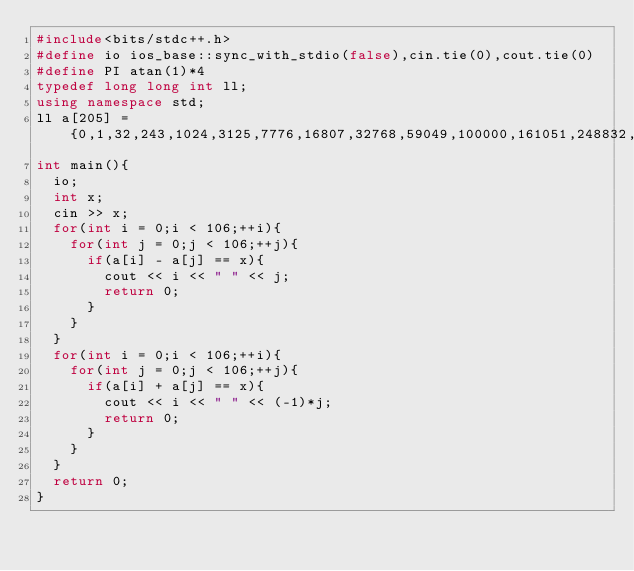<code> <loc_0><loc_0><loc_500><loc_500><_C++_>#include<bits/stdc++.h>
#define io ios_base::sync_with_stdio(false),cin.tie(0),cout.tie(0)
#define PI atan(1)*4
typedef long long int ll;
using namespace std;
ll a[205] = {0,1,32,243,1024,3125,7776,16807,32768,59049,100000,161051,248832,371293,537824,759375,1048576,1419857,1889568,2476099,3200000,4084101,5153632,6436343,7962624,9765625,11881376,14348907,17210368,20511149,24300000,28629151,33554432,39135393,45435424,52521875,60466176,69343957,79235168,90224199,102400000,115856201,130691232,147008443,164916224,184528125,205962976,229345007,254803968,282475249,312500000,345025251,380204032,418195493,459165024,503284375,550731776,601692057,656356768,714924299,777600000,844596301,916132832,992436543,1073741824,1160290625,1252332576,1350125107,1453933568,1564031349,1680700000,1804229351,1934917632,2073071593,2219006624,2373046875,2535525376,2706784157,2887174368,3077056399,3276800000,3486784401,3707398432,3939040643,4182119424,4437053125,4704270176,4984209207,5277319168,5584059449,5904900000,6240321451,6590815232,6956883693,7339040224,7737809375,8153726976,8587340257,9039207968,9509900499,10000000000,10510100501,11040808032,11592740743,12166529024};
int main(){
	io;
	int x;
	cin >> x;
	for(int i = 0;i < 106;++i){
		for(int j = 0;j < 106;++j){
			if(a[i] - a[j] == x){
				cout << i << " " << j;
				return 0;
			}
		}
	}
	for(int i = 0;i < 106;++i){
		for(int j = 0;j < 106;++j){
			if(a[i] + a[j] == x){
				cout << i << " " << (-1)*j;
				return 0;
			}
		}
	}
	return 0;
} </code> 